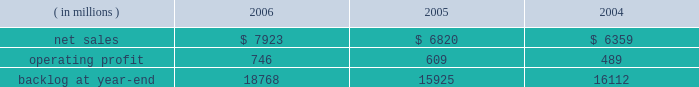Operating profit for the segment increased by 15% ( 15 % ) in 2005 compared to 2004 .
Operating profit increased by $ 80 million at m&fc mainly due to improved performance on fire control and air defense programs .
Performance on surface systems programs contributed to an increase in operating profit of $ 50 million at ms2 .
Pt&ts operating profit increased $ 10 million primarily due to improved performance on simulation and training programs .
The increase in backlog during 2006 over 2005 resulted primarily from increased orders on certain platform integration programs in pt&ts .
Space systems space systems 2019 operating results included the following : ( in millions ) 2006 2005 2004 .
Net sales for space systems increased by 16% ( 16 % ) in 2006 compared to 2005 .
During the year , sales growth in satellites and strategic & defensive missile systems ( s&dms ) offset declines in space transportation .
The $ 1.1 billion growth in satellites sales was mainly due to higher volume on both government and commercial satellite programs .
There were five commercial satellite deliveries in 2006 compared to no deliveries in 2005 .
Higher volume in both fleet ballistic missile and missile defense programs accounted for the $ 114 million sales increase at s&dms .
In space transportation , sales declined $ 102 million primarily due to lower volume in government space transportation activities on the titan and external tank programs .
Increased sales on the atlas evolved expendable launch vehicle launch capabilities ( elc ) contract partially offset the lower government space transportation sales .
Net sales for space systems increased by 7% ( 7 % ) in 2005 compared to 2004 .
During the year , sales growth in satellites and s&dms offset declines in space transportation .
The $ 410 million increase in satellites sales was due to higher volume on government satellite programs that more than offset declines in commercial satellite activities .
There were no commercial satellite deliveries in 2005 , compared to four in 2004 .
Increased sales of $ 235 million in s&dms were attributable to the fleet ballistic missile and missile defense programs .
The $ 180 million decrease in space transportation 2019s sales was mainly due to having three atlas launches in 2005 compared to six in 2004 .
Operating profit for the segment increased 22% ( 22 % ) in 2006 compared to 2005 .
Operating profit increased in satellites , space transportation and s&dms .
The $ 72 million growth in satellites operating profit was primarily driven by the volume and performance on government satellite programs and commercial satellite deliveries .
In space transportation , the $ 39 million growth in operating profit was attributable to improved performance on the atlas program resulting from risk reduction activities , including the first quarter definitization of the elc contract .
In s&dms , the $ 26 million increase in operating profit was due to higher volume and improved performance on both the fleet ballistic missile and missile defense programs .
Operating profit for the segment increased 25% ( 25 % ) in 2005 compared to 2004 .
Operating profit increased in space transportation , s&dms and satellites .
In space transportation , the $ 60 million increase in operating profit was primarily attributable to improved performance on the atlas vehicle program .
Satellites 2019 operating profit increased $ 35 million due to the higher volume and improved performance on government satellite programs , which more than offset the decreased operating profit due to the decline in commercial satellite deliveries .
The $ 20 million increase in s&dms was attributable to higher volume on fleet ballistic missile and missile defense programs .
In december 2006 , we completed a transaction with boeing to form ula , a joint venture which combines the production , engineering , test and launch operations associated with u.s .
Government launches of our atlas launch vehicles and boeing 2019s delta launch vehicles ( see related discussion on our 201cspace business 201d under 201cindustry considerations 201d ) .
We are accounting for our investment in ula under the equity method of accounting .
As a result , our share of the net earnings or losses of ula are included in other income and expenses , and we will no longer recognize sales related to launch vehicle services provided to the u.s .
Government .
In 2006 , we recorded sales to the u.s .
Government for atlas launch services totaling approximately $ 600 million .
We have retained the right to market commercial atlas launch services .
We contributed assets to ula , and ula assumed liabilities related to our atlas business in exchange for our 50% ( 50 % ) ownership interest .
The net book value of the assets contributed and liabilities assumed was approximately $ 200 million at .
What were average net sales for space systems from 2004 to 2006 , in millions? 
Computations: table_average(net sales, none)
Answer: 7034.0. 